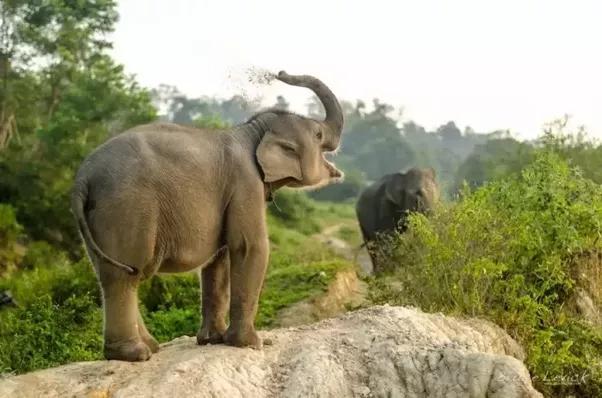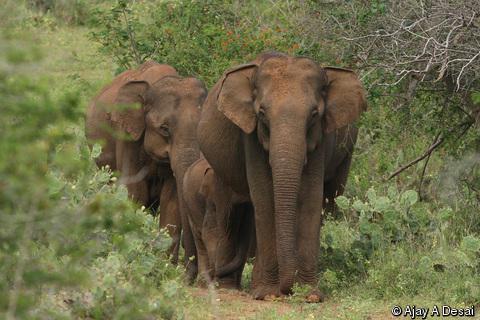The first image is the image on the left, the second image is the image on the right. Examine the images to the left and right. Is the description "There is one animal in the image on the right." accurate? Answer yes or no. No. 